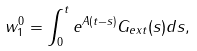Convert formula to latex. <formula><loc_0><loc_0><loc_500><loc_500>w _ { 1 } ^ { 0 } = \int _ { 0 } ^ { t } e ^ { A ( t - s ) } G _ { e x t } ( s ) d s ,</formula> 